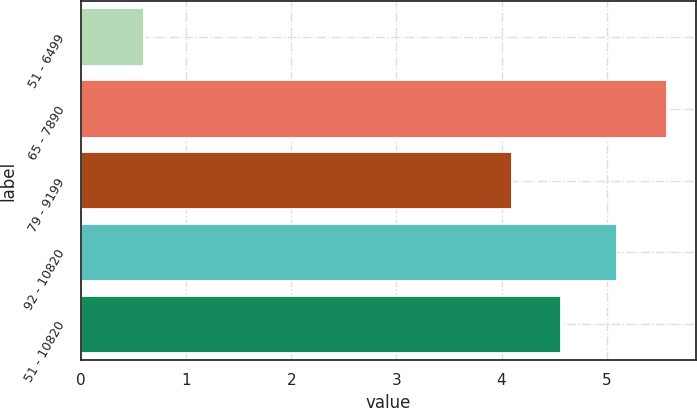<chart> <loc_0><loc_0><loc_500><loc_500><bar_chart><fcel>51 - 6499<fcel>65 - 7890<fcel>79 - 9199<fcel>92 - 10820<fcel>51 - 10820<nl><fcel>0.6<fcel>5.57<fcel>4.1<fcel>5.1<fcel>4.57<nl></chart> 